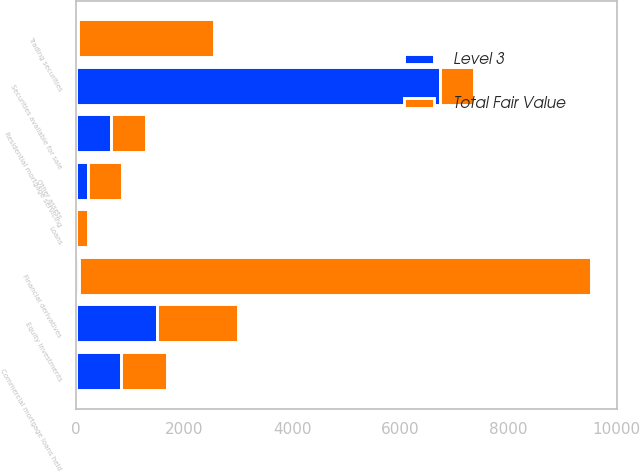<chart> <loc_0><loc_0><loc_500><loc_500><stacked_bar_chart><ecel><fcel>Securities available for sale<fcel>Financial derivatives<fcel>Trading securities<fcel>Residential mortgage servicing<fcel>Commercial mortgage loans held<fcel>Equity investments<fcel>Loans<fcel>Other assets<nl><fcel>Total Fair Value<fcel>647<fcel>9463<fcel>2513<fcel>647<fcel>843<fcel>1504<fcel>227<fcel>639<nl><fcel>Level 3<fcel>6729<fcel>67<fcel>39<fcel>647<fcel>843<fcel>1504<fcel>5<fcel>217<nl></chart> 